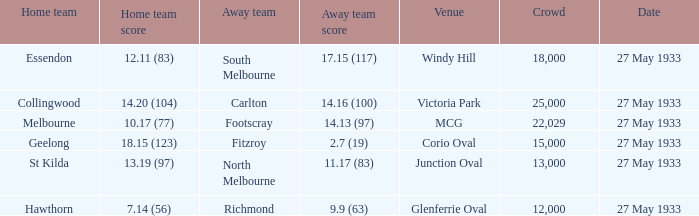In the match where the home team scored 14.20 (104), how many attendees were in the crowd? 25000.0. 